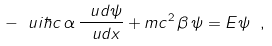<formula> <loc_0><loc_0><loc_500><loc_500>- \ u i \hbar { c } \, \alpha \, \frac { \ u d \psi } { \ u d x } + m c ^ { 2 } \, \beta \, \psi = E \psi \ ,</formula> 